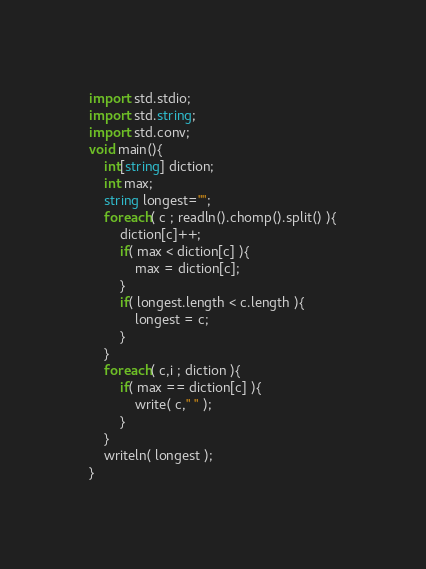Convert code to text. <code><loc_0><loc_0><loc_500><loc_500><_D_>import std.stdio;
import std.string;
import std.conv;
void main(){
	int[string] diction;
	int max;
	string longest="";
	foreach( c ; readln().chomp().split() ){
		diction[c]++;
		if( max < diction[c] ){
			max = diction[c];
		}
		if( longest.length < c.length ){
			longest = c;
		}
	}
	foreach( c,i ; diction ){
		if( max == diction[c] ){
			write( c," " );
		}
	}
	writeln( longest );
}</code> 